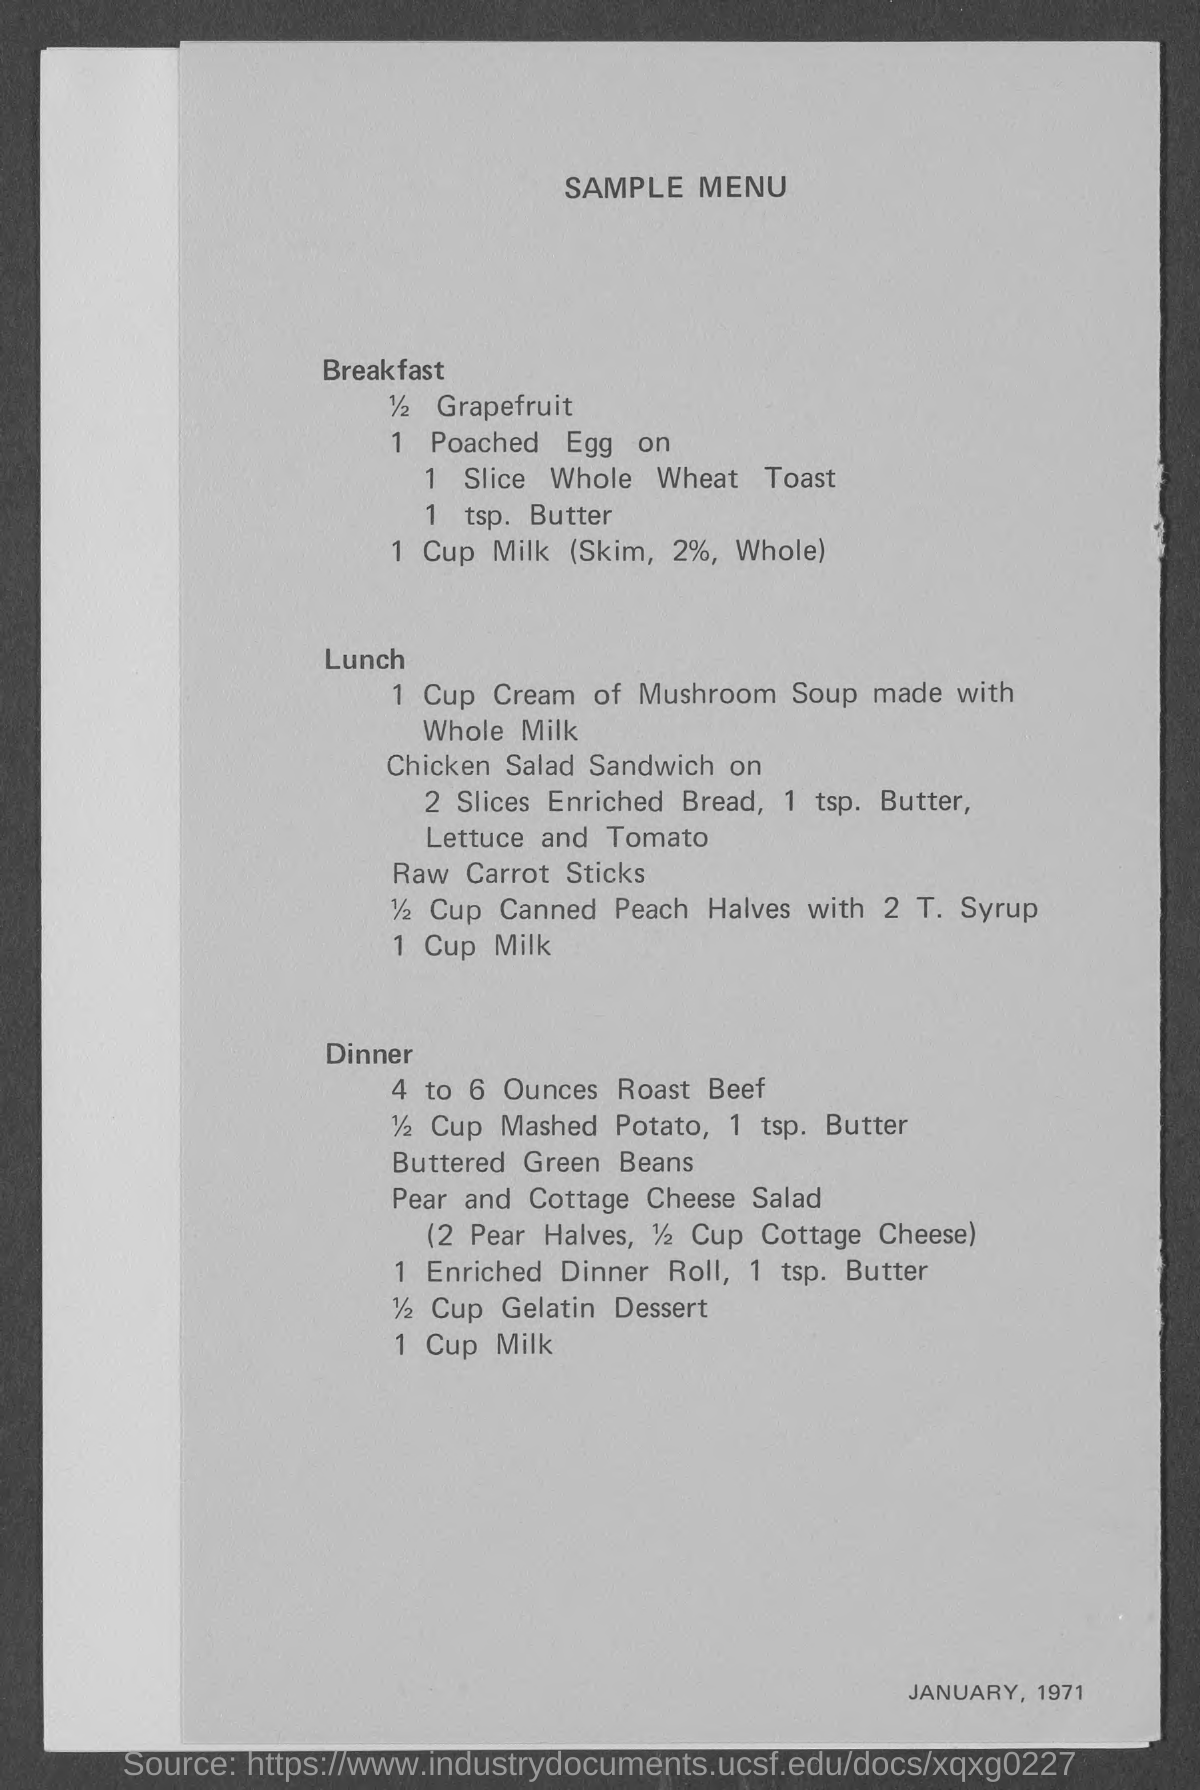What is the title of document?
Make the answer very short. SAMPLE MENU. How many slices of whole wheat toast?
Your answer should be very brief. 1 Slice whole wheat toast. 